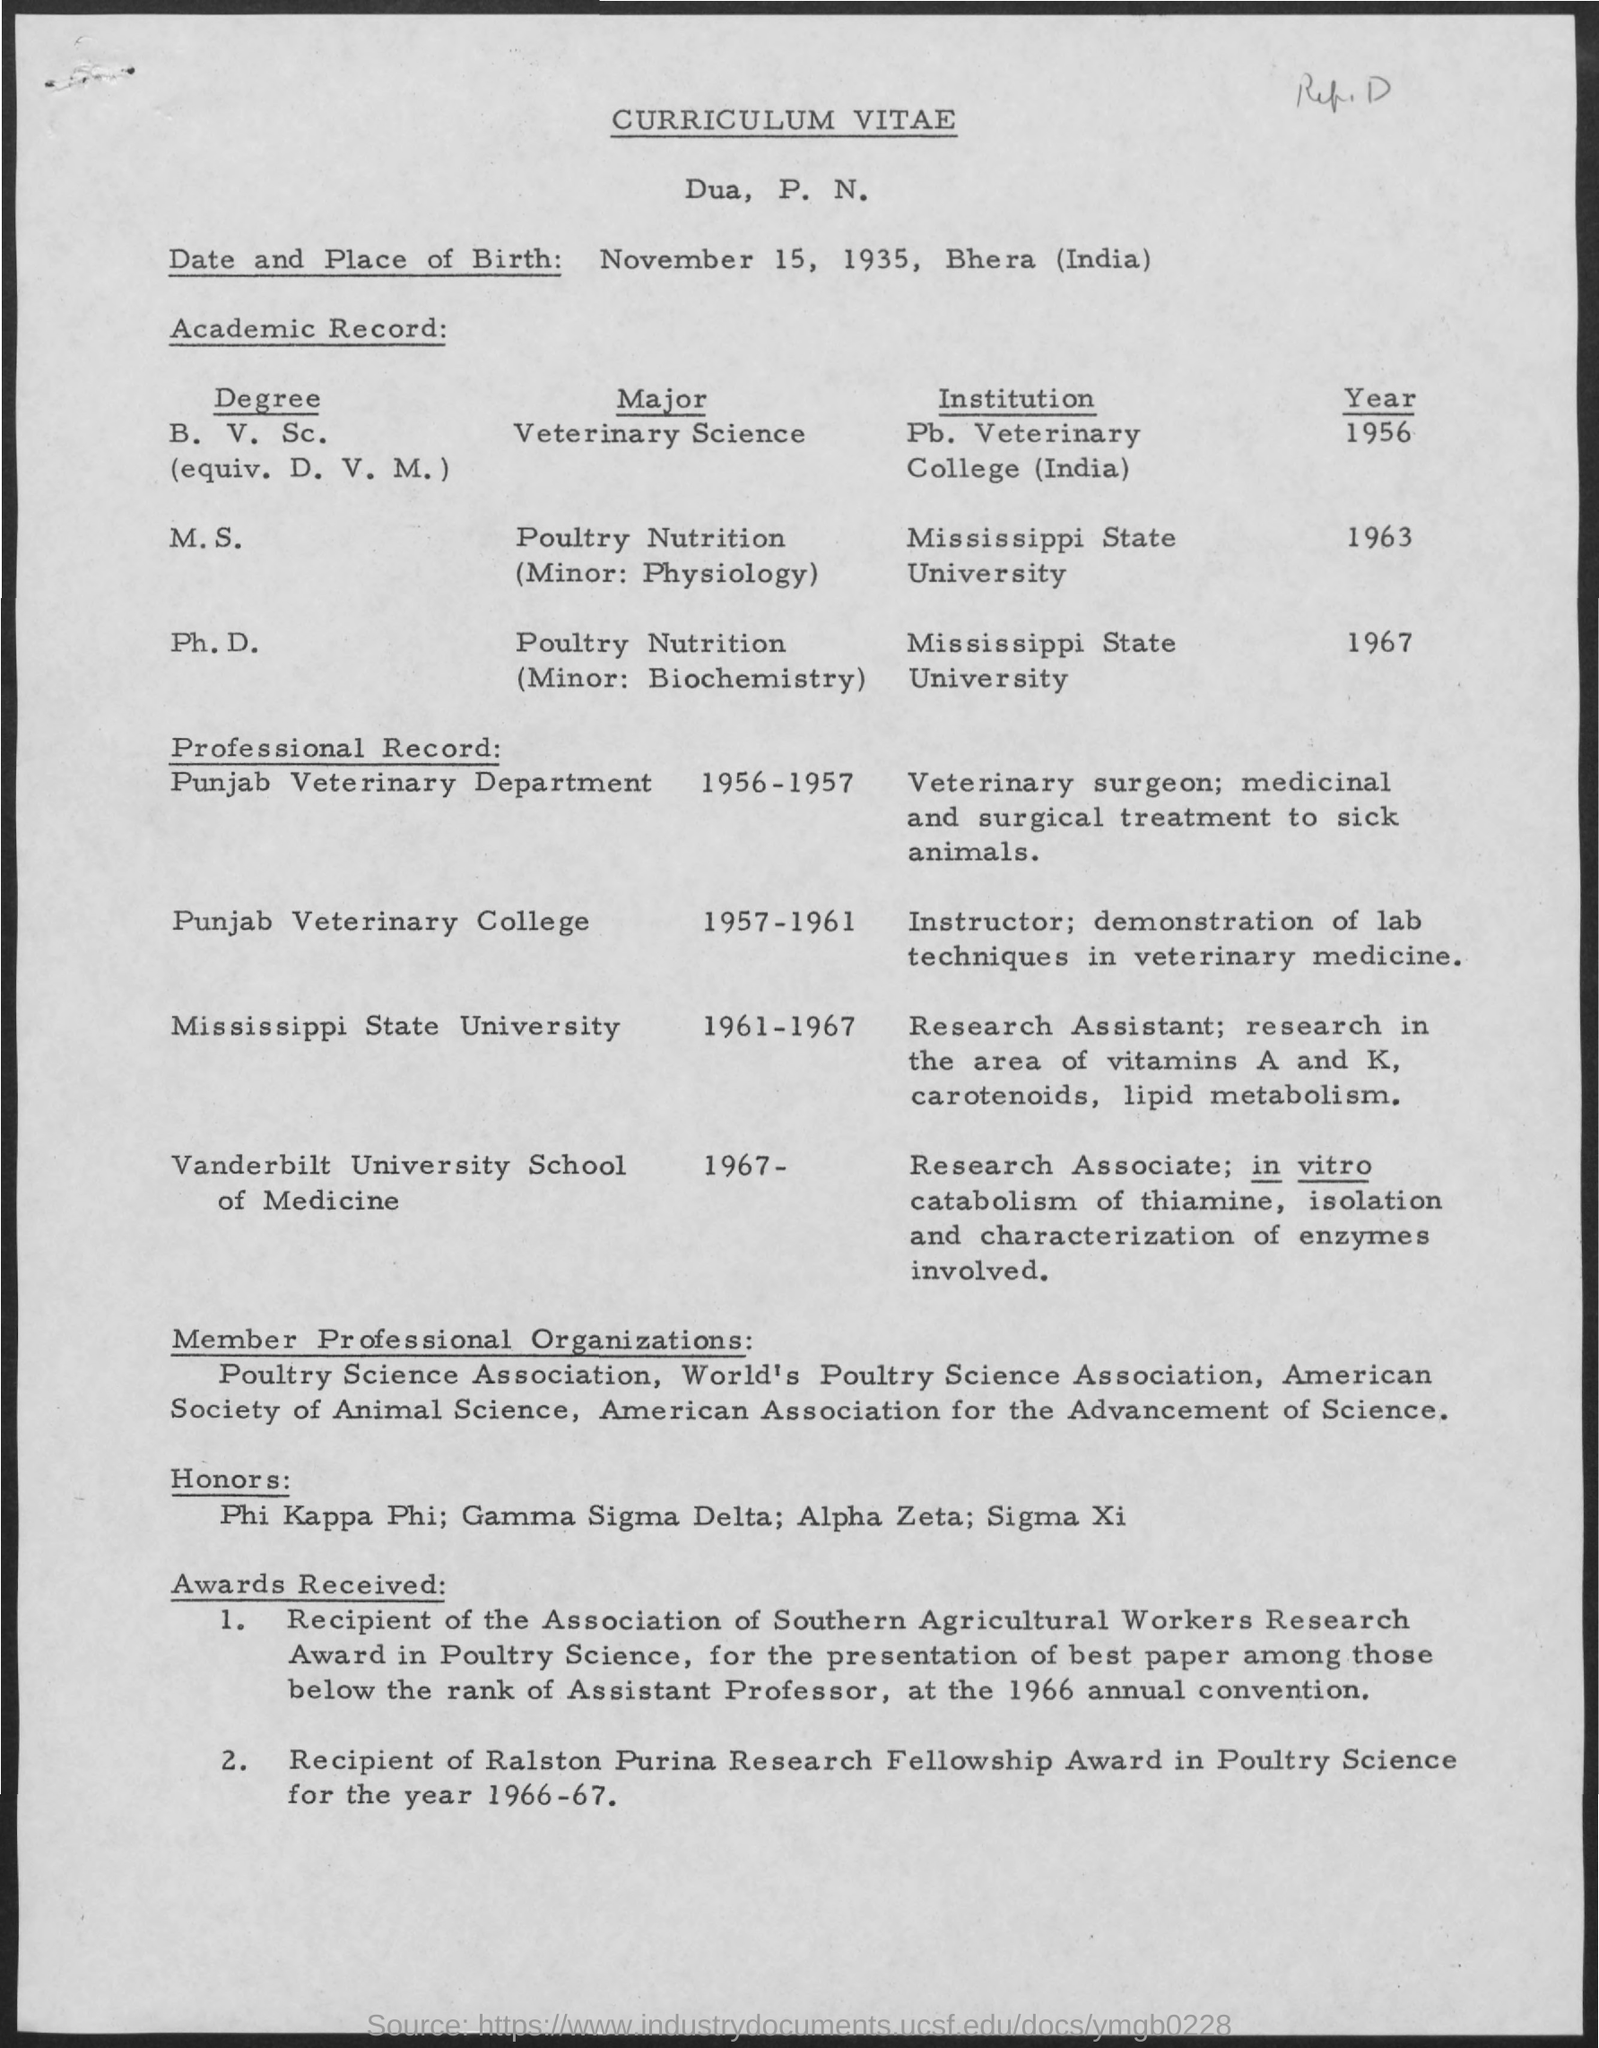Whose 's curriculum vitae is given here?
Your response must be concise. Dua, P. N. What is the date and place of birth of Dua, P. N.?
Provide a succinct answer. November 15, 1935, Bhera (India). In which institution, Dua, P. N. has completed a Ph.D. degree?
Your answer should be compact. Mississippi State University. In which year, Dua, P. N. has completed M.S. degree?
Offer a very short reply. 1963. What was the duty carried out by Dua, P. N. as a veterinary surgeon in Punjab Veterinary department?
Your answer should be compact. Medicinal and surgical treatment to sick animals. What was the duty carried out by Dua, P. N. as an instructor in Punjab Veterinary college?
Offer a very short reply. Demonstration of lab techniques in veterinary medicine. What was the job title of Dua, P. N. during the year 1961-1967?
Offer a terse response. Research Assistant. 